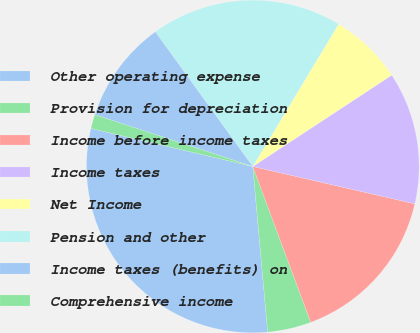<chart> <loc_0><loc_0><loc_500><loc_500><pie_chart><fcel>Other operating expense<fcel>Provision for depreciation<fcel>Income before income taxes<fcel>Income taxes<fcel>Net Income<fcel>Pension and other<fcel>Income taxes (benefits) on<fcel>Comprehensive income<nl><fcel>30.1%<fcel>4.24%<fcel>15.73%<fcel>12.86%<fcel>7.11%<fcel>18.6%<fcel>9.99%<fcel>1.37%<nl></chart> 